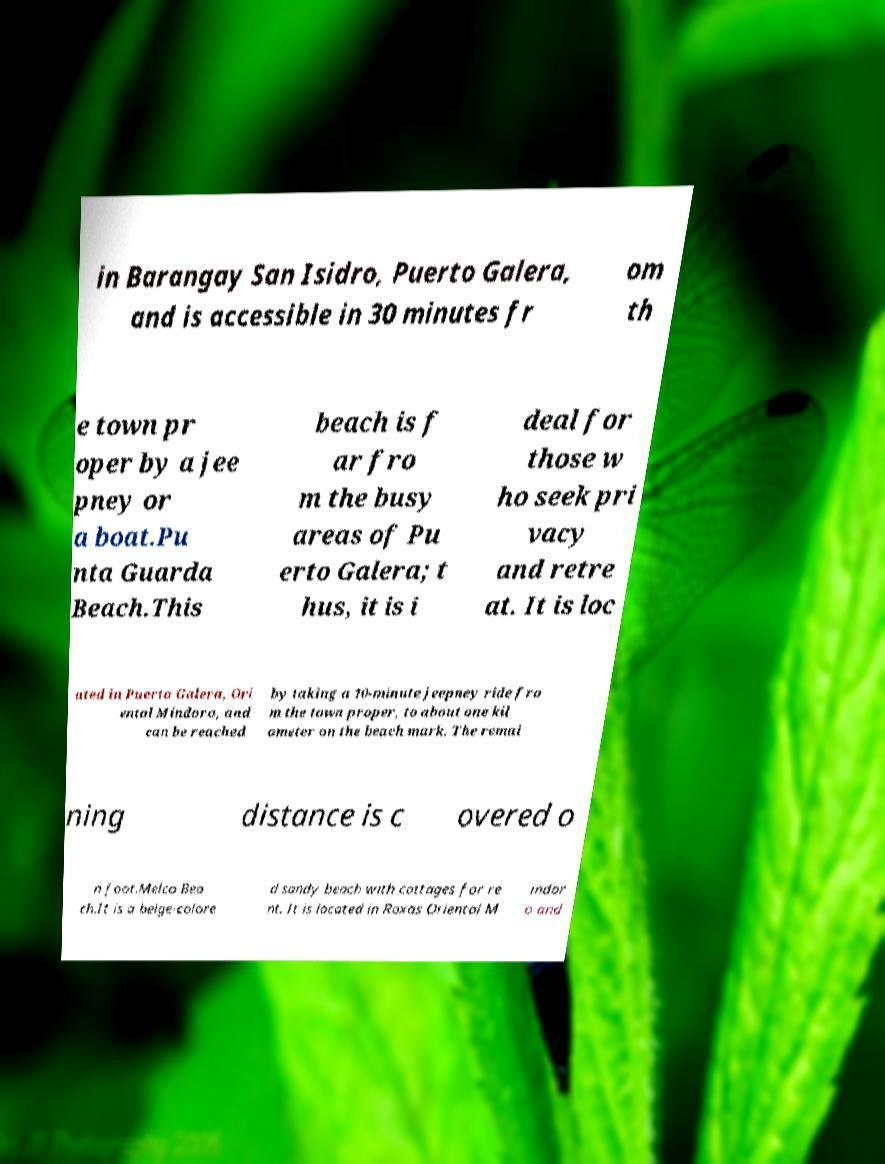Can you read and provide the text displayed in the image?This photo seems to have some interesting text. Can you extract and type it out for me? in Barangay San Isidro, Puerto Galera, and is accessible in 30 minutes fr om th e town pr oper by a jee pney or a boat.Pu nta Guarda Beach.This beach is f ar fro m the busy areas of Pu erto Galera; t hus, it is i deal for those w ho seek pri vacy and retre at. It is loc ated in Puerto Galera, Ori ental Mindoro, and can be reached by taking a 10-minute jeepney ride fro m the town proper, to about one kil ometer on the beach mark. The remai ning distance is c overed o n foot.Melco Bea ch.It is a beige-colore d sandy beach with cottages for re nt. It is located in Roxas Oriental M indor o and 